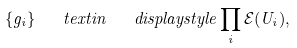Convert formula to latex. <formula><loc_0><loc_0><loc_500><loc_500>\{ g _ { i } \} \quad t e x t { i n } \quad d i s p l a y s t y l e \prod _ { i } \mathcal { E } ( U _ { i } ) ,</formula> 